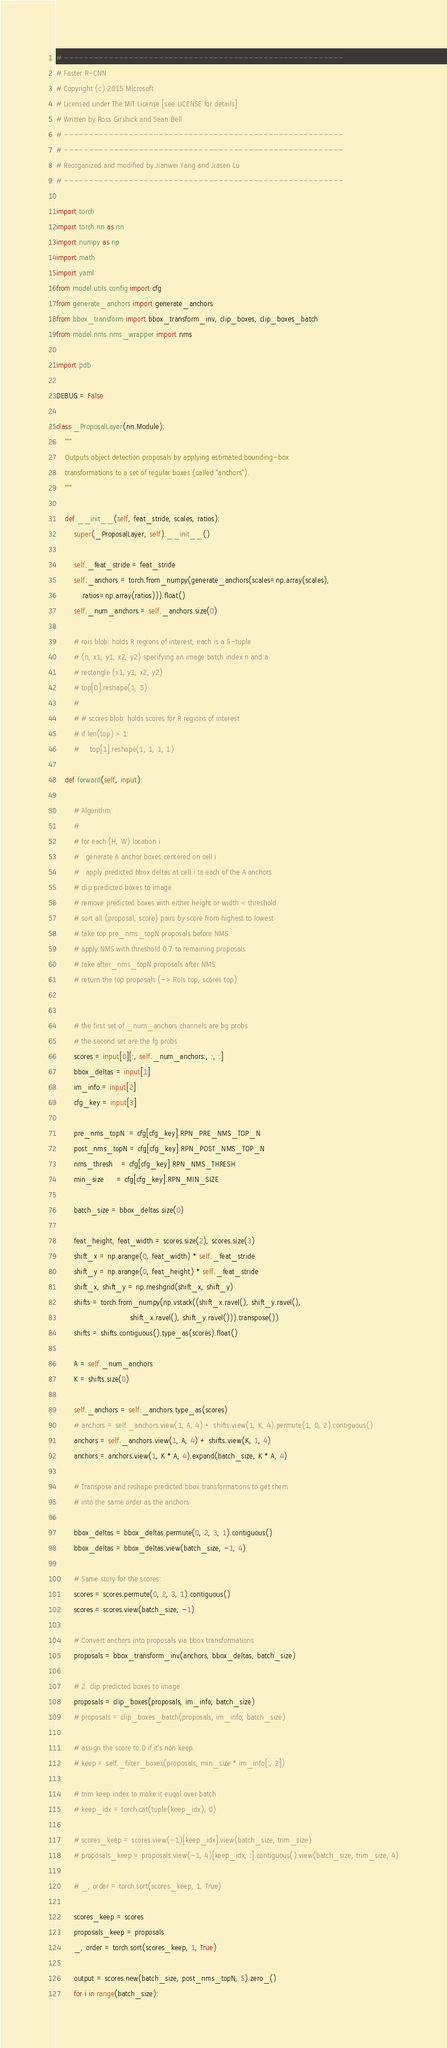<code> <loc_0><loc_0><loc_500><loc_500><_Python_># --------------------------------------------------------
# Faster R-CNN
# Copyright (c) 2015 Microsoft
# Licensed under The MIT License [see LICENSE for details]
# Written by Ross Girshick and Sean Bell
# --------------------------------------------------------
# --------------------------------------------------------
# Reorganized and modified by Jianwei Yang and Jiasen Lu
# --------------------------------------------------------

import torch
import torch.nn as nn
import numpy as np
import math
import yaml
from model.utils.config import cfg
from generate_anchors import generate_anchors
from bbox_transform import bbox_transform_inv, clip_boxes, clip_boxes_batch
from model.nms.nms_wrapper import nms

import pdb

DEBUG = False

class _ProposalLayer(nn.Module):
    """
    Outputs object detection proposals by applying estimated bounding-box
    transformations to a set of regular boxes (called "anchors").
    """

    def __init__(self, feat_stride, scales, ratios):
        super(_ProposalLayer, self).__init__()

        self._feat_stride = feat_stride
        self._anchors = torch.from_numpy(generate_anchors(scales=np.array(scales), 
            ratios=np.array(ratios))).float()
        self._num_anchors = self._anchors.size(0)

        # rois blob: holds R regions of interest, each is a 5-tuple
        # (n, x1, y1, x2, y2) specifying an image batch index n and a
        # rectangle (x1, y1, x2, y2)
        # top[0].reshape(1, 5)
        #
        # # scores blob: holds scores for R regions of interest
        # if len(top) > 1:
        #     top[1].reshape(1, 1, 1, 1)

    def forward(self, input):

        # Algorithm:
        #
        # for each (H, W) location i
        #   generate A anchor boxes centered on cell i
        #   apply predicted bbox deltas at cell i to each of the A anchors
        # clip predicted boxes to image
        # remove predicted boxes with either height or width < threshold
        # sort all (proposal, score) pairs by score from highest to lowest
        # take top pre_nms_topN proposals before NMS
        # apply NMS with threshold 0.7 to remaining proposals
        # take after_nms_topN proposals after NMS
        # return the top proposals (-> RoIs top, scores top)


        # the first set of _num_anchors channels are bg probs
        # the second set are the fg probs
        scores = input[0][:, self._num_anchors:, :, :]
        bbox_deltas = input[1]
        im_info = input[2]
        cfg_key = input[3]

        pre_nms_topN  = cfg[cfg_key].RPN_PRE_NMS_TOP_N
        post_nms_topN = cfg[cfg_key].RPN_POST_NMS_TOP_N
        nms_thresh    = cfg[cfg_key].RPN_NMS_THRESH
        min_size      = cfg[cfg_key].RPN_MIN_SIZE

        batch_size = bbox_deltas.size(0)

        feat_height, feat_width = scores.size(2), scores.size(3)
        shift_x = np.arange(0, feat_width) * self._feat_stride
        shift_y = np.arange(0, feat_height) * self._feat_stride
        shift_x, shift_y = np.meshgrid(shift_x, shift_y)
        shifts = torch.from_numpy(np.vstack((shift_x.ravel(), shift_y.ravel(),
                                  shift_x.ravel(), shift_y.ravel())).transpose())
        shifts = shifts.contiguous().type_as(scores).float()

        A = self._num_anchors
        K = shifts.size(0)

        self._anchors = self._anchors.type_as(scores)
        # anchors = self._anchors.view(1, A, 4) + shifts.view(1, K, 4).permute(1, 0, 2).contiguous()
        anchors = self._anchors.view(1, A, 4) + shifts.view(K, 1, 4)
        anchors = anchors.view(1, K * A, 4).expand(batch_size, K * A, 4)

        # Transpose and reshape predicted bbox transformations to get them
        # into the same order as the anchors:

        bbox_deltas = bbox_deltas.permute(0, 2, 3, 1).contiguous()
        bbox_deltas = bbox_deltas.view(batch_size, -1, 4)

        # Same story for the scores:
        scores = scores.permute(0, 2, 3, 1).contiguous()
        scores = scores.view(batch_size, -1)

        # Convert anchors into proposals via bbox transformations
        proposals = bbox_transform_inv(anchors, bbox_deltas, batch_size)

        # 2. clip predicted boxes to image
        proposals = clip_boxes(proposals, im_info, batch_size)
        # proposals = clip_boxes_batch(proposals, im_info, batch_size)

        # assign the score to 0 if it's non keep.
        # keep = self._filter_boxes(proposals, min_size * im_info[:, 2])

        # trim keep index to make it euqal over batch
        # keep_idx = torch.cat(tuple(keep_idx), 0)

        # scores_keep = scores.view(-1)[keep_idx].view(batch_size, trim_size)
        # proposals_keep = proposals.view(-1, 4)[keep_idx, :].contiguous().view(batch_size, trim_size, 4)
        
        # _, order = torch.sort(scores_keep, 1, True)
        
        scores_keep = scores
        proposals_keep = proposals
        _, order = torch.sort(scores_keep, 1, True)

        output = scores.new(batch_size, post_nms_topN, 5).zero_()
        for i in range(batch_size):</code> 